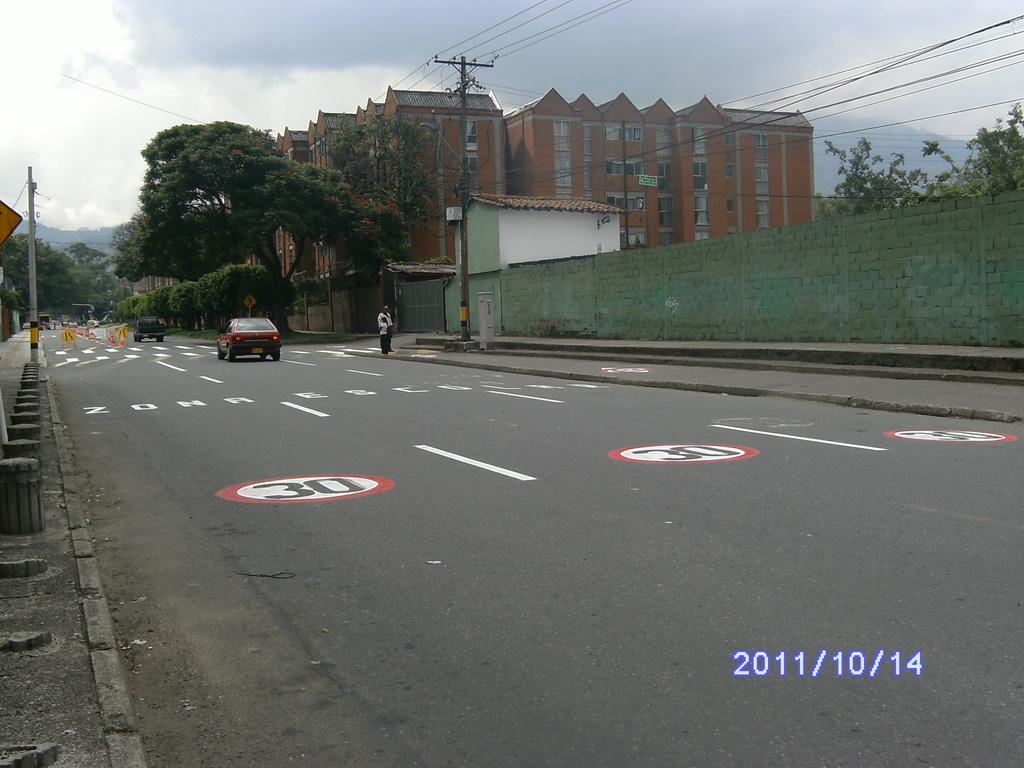Describe this image in one or two sentences. This picture might be taken on the wide road. In this image, we can see few vehicles which are moving on the road. On the right side, we can see a person standing on the footpath, brick wall, trees, electric wires, building, glass window, house, mountains. On the left side, we can see some pillars, pole, trees. In the background, we can see some mountains. At the top, we can see a sky which cloudy, at the bottom, we can see a road and a footpath. 